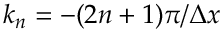Convert formula to latex. <formula><loc_0><loc_0><loc_500><loc_500>k _ { n } = - ( 2 n + 1 ) \pi / \Delta x</formula> 